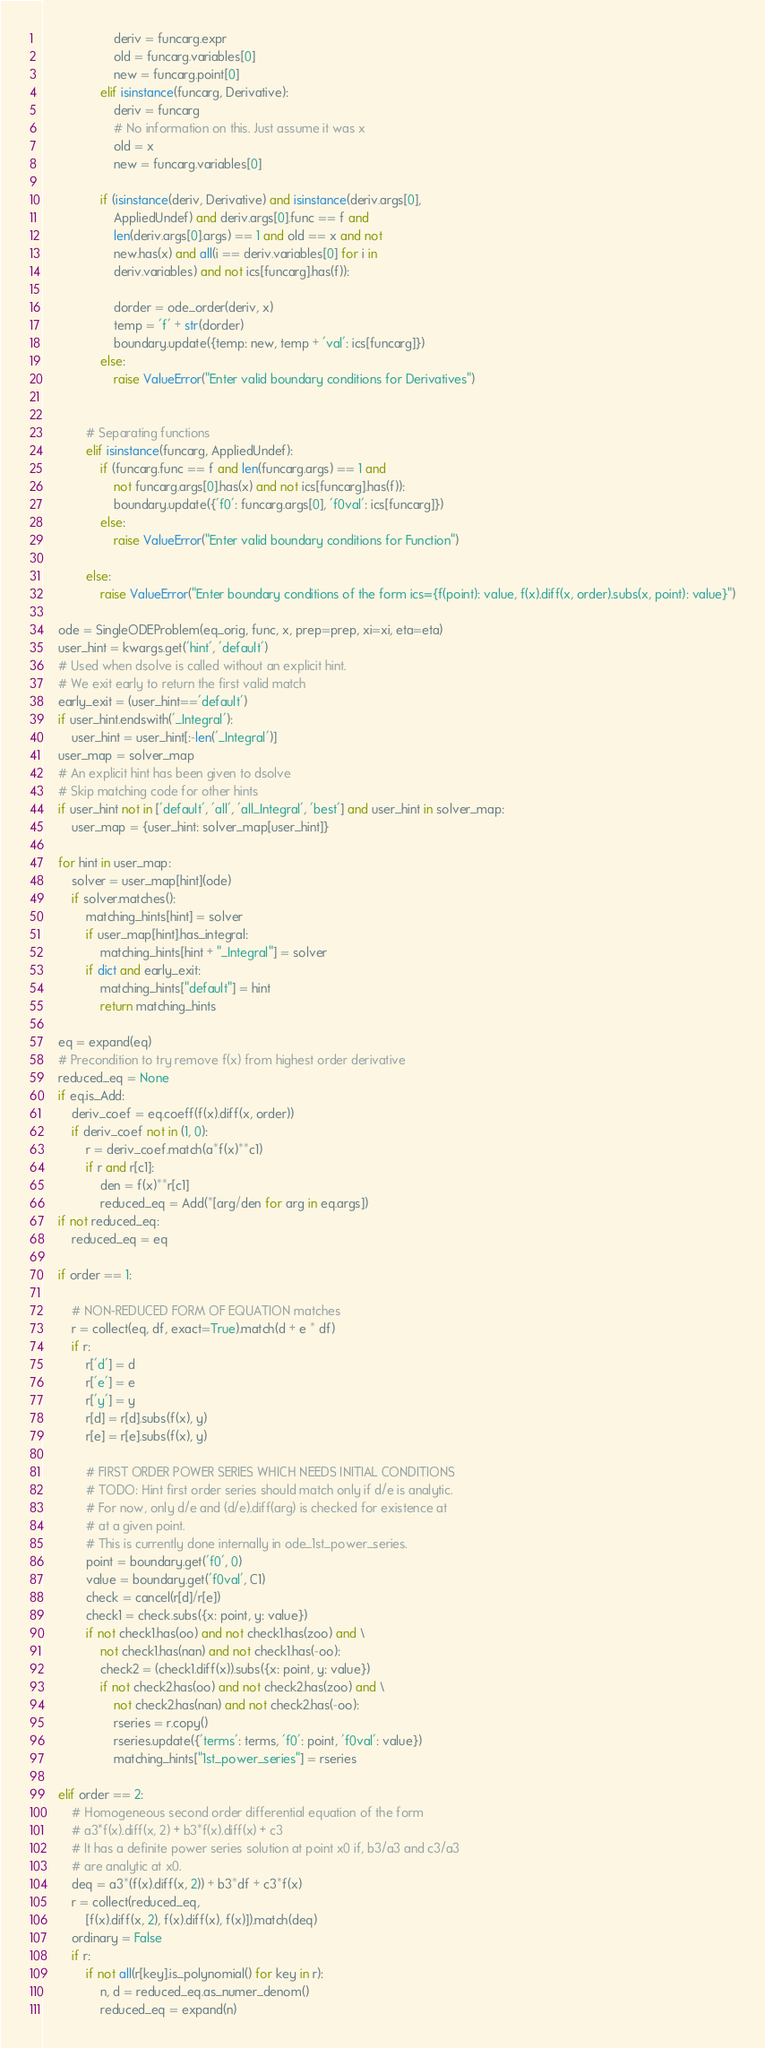<code> <loc_0><loc_0><loc_500><loc_500><_Python_>                    deriv = funcarg.expr
                    old = funcarg.variables[0]
                    new = funcarg.point[0]
                elif isinstance(funcarg, Derivative):
                    deriv = funcarg
                    # No information on this. Just assume it was x
                    old = x
                    new = funcarg.variables[0]

                if (isinstance(deriv, Derivative) and isinstance(deriv.args[0],
                    AppliedUndef) and deriv.args[0].func == f and
                    len(deriv.args[0].args) == 1 and old == x and not
                    new.has(x) and all(i == deriv.variables[0] for i in
                    deriv.variables) and not ics[funcarg].has(f)):

                    dorder = ode_order(deriv, x)
                    temp = 'f' + str(dorder)
                    boundary.update({temp: new, temp + 'val': ics[funcarg]})
                else:
                    raise ValueError("Enter valid boundary conditions for Derivatives")


            # Separating functions
            elif isinstance(funcarg, AppliedUndef):
                if (funcarg.func == f and len(funcarg.args) == 1 and
                    not funcarg.args[0].has(x) and not ics[funcarg].has(f)):
                    boundary.update({'f0': funcarg.args[0], 'f0val': ics[funcarg]})
                else:
                    raise ValueError("Enter valid boundary conditions for Function")

            else:
                raise ValueError("Enter boundary conditions of the form ics={f(point): value, f(x).diff(x, order).subs(x, point): value}")

    ode = SingleODEProblem(eq_orig, func, x, prep=prep, xi=xi, eta=eta)
    user_hint = kwargs.get('hint', 'default')
    # Used when dsolve is called without an explicit hint.
    # We exit early to return the first valid match
    early_exit = (user_hint=='default')
    if user_hint.endswith('_Integral'):
        user_hint = user_hint[:-len('_Integral')]
    user_map = solver_map
    # An explicit hint has been given to dsolve
    # Skip matching code for other hints
    if user_hint not in ['default', 'all', 'all_Integral', 'best'] and user_hint in solver_map:
        user_map = {user_hint: solver_map[user_hint]}

    for hint in user_map:
        solver = user_map[hint](ode)
        if solver.matches():
            matching_hints[hint] = solver
            if user_map[hint].has_integral:
                matching_hints[hint + "_Integral"] = solver
            if dict and early_exit:
                matching_hints["default"] = hint
                return matching_hints

    eq = expand(eq)
    # Precondition to try remove f(x) from highest order derivative
    reduced_eq = None
    if eq.is_Add:
        deriv_coef = eq.coeff(f(x).diff(x, order))
        if deriv_coef not in (1, 0):
            r = deriv_coef.match(a*f(x)**c1)
            if r and r[c1]:
                den = f(x)**r[c1]
                reduced_eq = Add(*[arg/den for arg in eq.args])
    if not reduced_eq:
        reduced_eq = eq

    if order == 1:

        # NON-REDUCED FORM OF EQUATION matches
        r = collect(eq, df, exact=True).match(d + e * df)
        if r:
            r['d'] = d
            r['e'] = e
            r['y'] = y
            r[d] = r[d].subs(f(x), y)
            r[e] = r[e].subs(f(x), y)

            # FIRST ORDER POWER SERIES WHICH NEEDS INITIAL CONDITIONS
            # TODO: Hint first order series should match only if d/e is analytic.
            # For now, only d/e and (d/e).diff(arg) is checked for existence at
            # at a given point.
            # This is currently done internally in ode_1st_power_series.
            point = boundary.get('f0', 0)
            value = boundary.get('f0val', C1)
            check = cancel(r[d]/r[e])
            check1 = check.subs({x: point, y: value})
            if not check1.has(oo) and not check1.has(zoo) and \
                not check1.has(nan) and not check1.has(-oo):
                check2 = (check1.diff(x)).subs({x: point, y: value})
                if not check2.has(oo) and not check2.has(zoo) and \
                    not check2.has(nan) and not check2.has(-oo):
                    rseries = r.copy()
                    rseries.update({'terms': terms, 'f0': point, 'f0val': value})
                    matching_hints["1st_power_series"] = rseries

    elif order == 2:
        # Homogeneous second order differential equation of the form
        # a3*f(x).diff(x, 2) + b3*f(x).diff(x) + c3
        # It has a definite power series solution at point x0 if, b3/a3 and c3/a3
        # are analytic at x0.
        deq = a3*(f(x).diff(x, 2)) + b3*df + c3*f(x)
        r = collect(reduced_eq,
            [f(x).diff(x, 2), f(x).diff(x), f(x)]).match(deq)
        ordinary = False
        if r:
            if not all(r[key].is_polynomial() for key in r):
                n, d = reduced_eq.as_numer_denom()
                reduced_eq = expand(n)</code> 